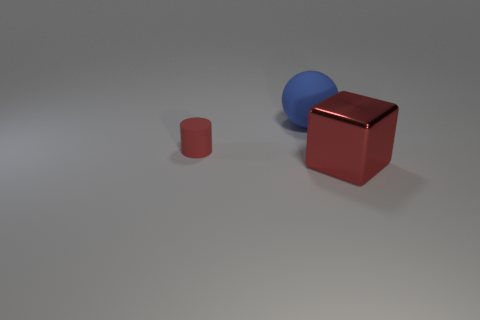Is there anything else that is the same material as the red block?
Your answer should be very brief. No. Is there any other thing that has the same shape as the big metallic object?
Your answer should be compact. No. Is there anything else that has the same size as the cylinder?
Give a very brief answer. No. What size is the thing that is behind the rubber object on the left side of the big blue matte thing?
Your response must be concise. Large. How many large things are either metal things or red rubber spheres?
Offer a terse response. 1. What number of other things are the same color as the sphere?
Keep it short and to the point. 0. Does the matte object left of the big sphere have the same size as the object that is in front of the small rubber object?
Keep it short and to the point. No. Is the material of the cylinder the same as the object in front of the tiny red matte object?
Your answer should be compact. No. Is the number of blue matte balls in front of the large rubber sphere greater than the number of blue things that are on the left side of the small red rubber thing?
Your answer should be compact. No. There is a thing behind the rubber object that is left of the blue thing; what is its color?
Offer a terse response. Blue. 